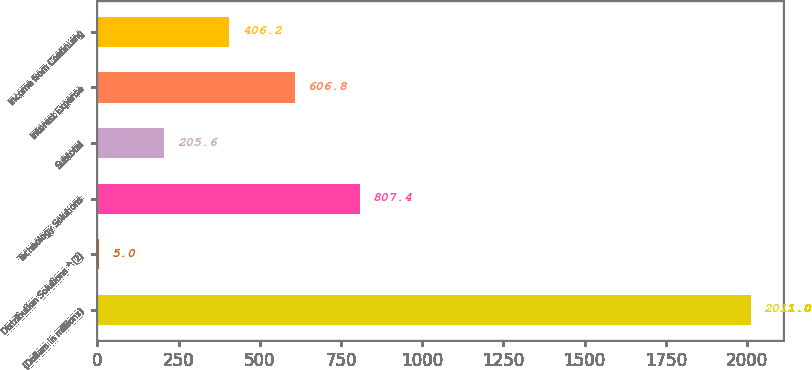Convert chart to OTSL. <chart><loc_0><loc_0><loc_500><loc_500><bar_chart><fcel>(Dollars in millions)<fcel>Distribution Solutions ^(2)<fcel>Technology Solutions<fcel>Subtotal<fcel>Interest Expense<fcel>Income from Continuing<nl><fcel>2011<fcel>5<fcel>807.4<fcel>205.6<fcel>606.8<fcel>406.2<nl></chart> 